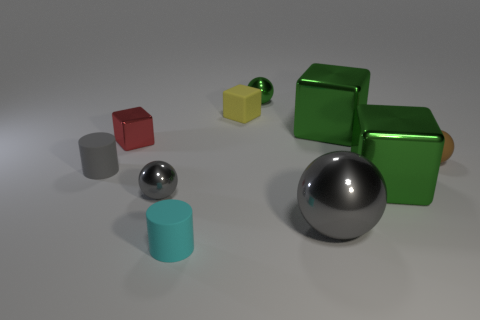What number of objects are green shiny objects that are behind the tiny brown thing or small gray things?
Your response must be concise. 4. What number of other objects are there of the same shape as the gray rubber object?
Your response must be concise. 1. Is the number of rubber cylinders behind the small gray sphere greater than the number of small blocks?
Ensure brevity in your answer.  No. There is a gray rubber thing that is the same shape as the cyan object; what size is it?
Offer a very short reply. Small. Is there anything else that has the same material as the brown sphere?
Provide a succinct answer. Yes. The red shiny object is what shape?
Ensure brevity in your answer.  Cube. What shape is the yellow thing that is the same size as the cyan rubber cylinder?
Offer a terse response. Cube. Is there anything else that is the same color as the matte ball?
Provide a succinct answer. No. There is a cyan cylinder that is made of the same material as the small gray cylinder; what size is it?
Your answer should be very brief. Small. Do the gray matte object and the large shiny object behind the small brown matte thing have the same shape?
Provide a short and direct response. No. 